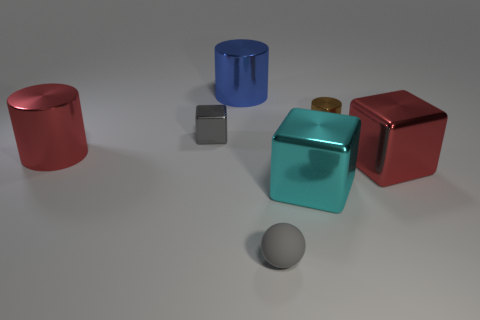How big is the brown thing on the right side of the gray metal cube?
Make the answer very short. Small. What number of red metal things are the same size as the cyan cube?
Provide a succinct answer. 2. There is a object that is both left of the large cyan cube and in front of the red metallic cylinder; what material is it?
Keep it short and to the point. Rubber. What is the material of the brown cylinder that is the same size as the gray cube?
Provide a short and direct response. Metal. There is a gray metal cube that is behind the large red shiny thing that is right of the big cyan metallic thing right of the small gray sphere; how big is it?
Your answer should be compact. Small. There is a gray cube that is made of the same material as the small brown cylinder; what size is it?
Your answer should be compact. Small. There is a cyan cube; is it the same size as the gray object that is in front of the red block?
Ensure brevity in your answer.  No. The red thing on the right side of the brown thing has what shape?
Make the answer very short. Cube. There is a large object in front of the big metallic thing right of the cyan metallic cube; are there any red cylinders in front of it?
Offer a terse response. No. There is a red thing that is the same shape as the large cyan thing; what material is it?
Your response must be concise. Metal. 